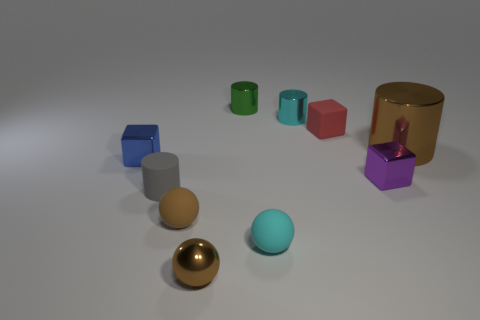Subtract all brown balls. How many were subtracted if there are1brown balls left? 1 Subtract 1 spheres. How many spheres are left? 2 Subtract all cylinders. How many objects are left? 6 Add 4 red things. How many red things exist? 5 Subtract 0 purple cylinders. How many objects are left? 10 Subtract all small cubes. Subtract all tiny brown objects. How many objects are left? 5 Add 1 tiny gray rubber objects. How many tiny gray rubber objects are left? 2 